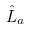Convert formula to latex. <formula><loc_0><loc_0><loc_500><loc_500>\hat { L } _ { a }</formula> 